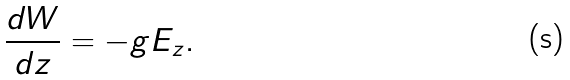<formula> <loc_0><loc_0><loc_500><loc_500>\frac { d W } { d z } = - g E _ { z } .</formula> 